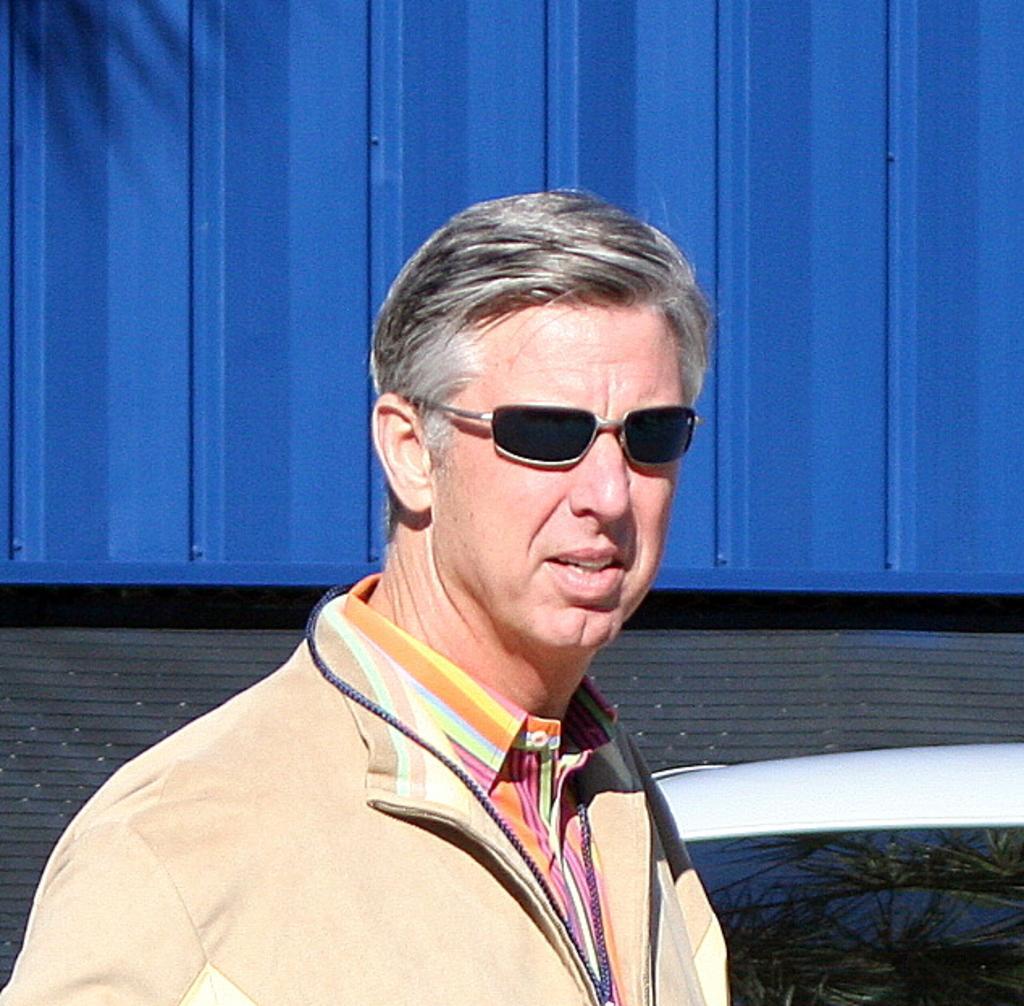Could you give a brief overview of what you see in this image? In this picture I can see a man wearing sunglasses and I can see a car and looks like a metal container in the background. 